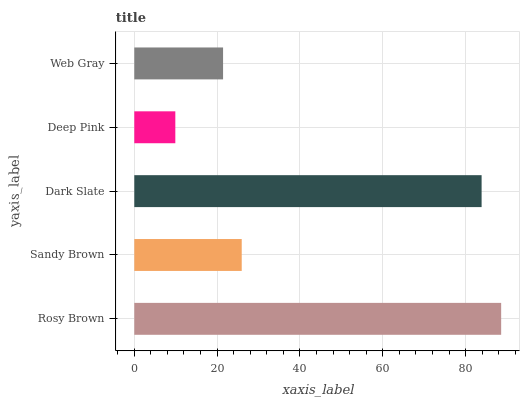Is Deep Pink the minimum?
Answer yes or no. Yes. Is Rosy Brown the maximum?
Answer yes or no. Yes. Is Sandy Brown the minimum?
Answer yes or no. No. Is Sandy Brown the maximum?
Answer yes or no. No. Is Rosy Brown greater than Sandy Brown?
Answer yes or no. Yes. Is Sandy Brown less than Rosy Brown?
Answer yes or no. Yes. Is Sandy Brown greater than Rosy Brown?
Answer yes or no. No. Is Rosy Brown less than Sandy Brown?
Answer yes or no. No. Is Sandy Brown the high median?
Answer yes or no. Yes. Is Sandy Brown the low median?
Answer yes or no. Yes. Is Deep Pink the high median?
Answer yes or no. No. Is Deep Pink the low median?
Answer yes or no. No. 